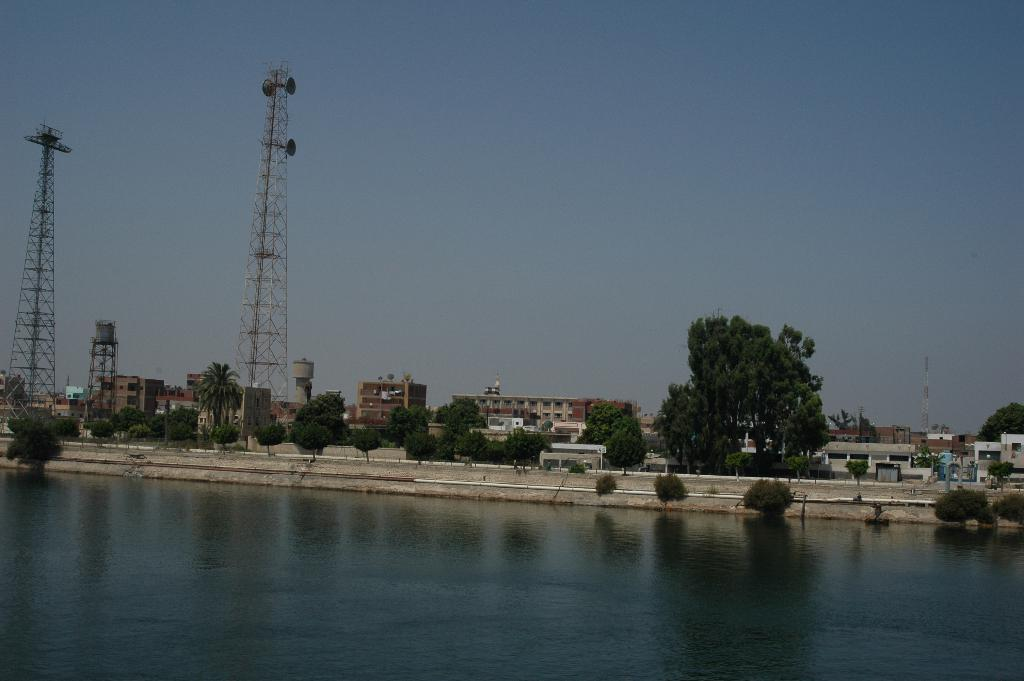What type of structures can be seen in the image? There are buildings and towers in the image. What natural elements are present in the image? There are trees and plants in the image. What is the color of the sky in the image? The sky is blue in the image. Can you see a spy hiding behind the trees in the image? There is no indication of a spy or any person in the image; it only features buildings, towers, trees, plants, water, and a blue sky. What type of pear is hanging from the tower in the image? There is no pear present in the image; it only features buildings, towers, trees, plants, water, and a blue sky. 